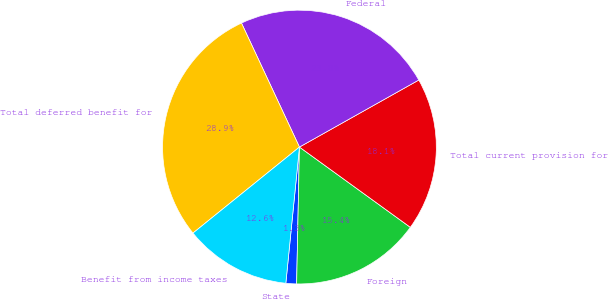<chart> <loc_0><loc_0><loc_500><loc_500><pie_chart><fcel>State<fcel>Foreign<fcel>Total current provision for<fcel>Federal<fcel>Total deferred benefit for<fcel>Benefit from income taxes<nl><fcel>1.26%<fcel>15.36%<fcel>18.12%<fcel>23.82%<fcel>28.86%<fcel>12.6%<nl></chart> 